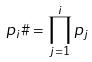Convert formula to latex. <formula><loc_0><loc_0><loc_500><loc_500>p _ { i } \# = \prod _ { j = 1 } ^ { i } p _ { j }</formula> 